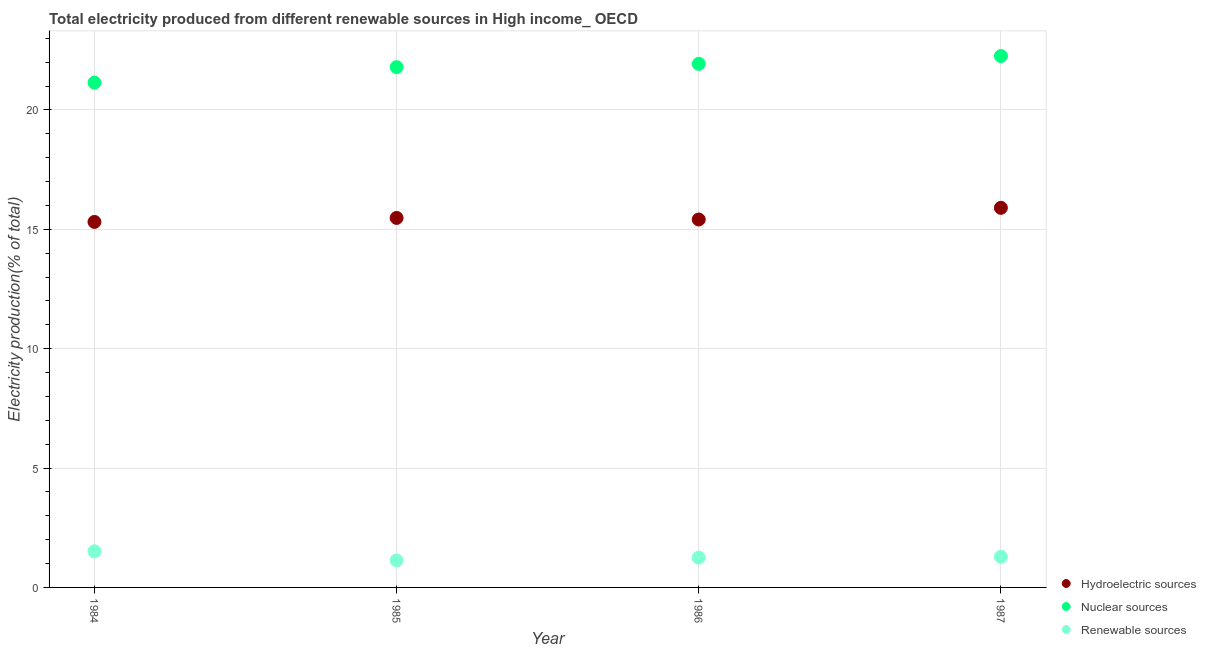How many different coloured dotlines are there?
Your answer should be compact. 3. Is the number of dotlines equal to the number of legend labels?
Ensure brevity in your answer.  Yes. What is the percentage of electricity produced by hydroelectric sources in 1987?
Ensure brevity in your answer.  15.9. Across all years, what is the maximum percentage of electricity produced by hydroelectric sources?
Keep it short and to the point. 15.9. Across all years, what is the minimum percentage of electricity produced by hydroelectric sources?
Provide a short and direct response. 15.31. What is the total percentage of electricity produced by hydroelectric sources in the graph?
Provide a succinct answer. 62.1. What is the difference between the percentage of electricity produced by nuclear sources in 1984 and that in 1985?
Your answer should be compact. -0.65. What is the difference between the percentage of electricity produced by renewable sources in 1985 and the percentage of electricity produced by nuclear sources in 1984?
Make the answer very short. -20.01. What is the average percentage of electricity produced by hydroelectric sources per year?
Offer a very short reply. 15.53. In the year 1986, what is the difference between the percentage of electricity produced by hydroelectric sources and percentage of electricity produced by nuclear sources?
Make the answer very short. -6.52. In how many years, is the percentage of electricity produced by renewable sources greater than 13 %?
Provide a short and direct response. 0. What is the ratio of the percentage of electricity produced by renewable sources in 1984 to that in 1987?
Your answer should be compact. 1.18. What is the difference between the highest and the second highest percentage of electricity produced by nuclear sources?
Ensure brevity in your answer.  0.33. What is the difference between the highest and the lowest percentage of electricity produced by renewable sources?
Provide a succinct answer. 0.38. In how many years, is the percentage of electricity produced by hydroelectric sources greater than the average percentage of electricity produced by hydroelectric sources taken over all years?
Ensure brevity in your answer.  1. Is the sum of the percentage of electricity produced by nuclear sources in 1985 and 1986 greater than the maximum percentage of electricity produced by hydroelectric sources across all years?
Your response must be concise. Yes. Is it the case that in every year, the sum of the percentage of electricity produced by hydroelectric sources and percentage of electricity produced by nuclear sources is greater than the percentage of electricity produced by renewable sources?
Provide a short and direct response. Yes. Is the percentage of electricity produced by nuclear sources strictly less than the percentage of electricity produced by renewable sources over the years?
Offer a very short reply. No. How many years are there in the graph?
Your answer should be compact. 4. What is the difference between two consecutive major ticks on the Y-axis?
Make the answer very short. 5. Are the values on the major ticks of Y-axis written in scientific E-notation?
Provide a succinct answer. No. Does the graph contain grids?
Make the answer very short. Yes. Where does the legend appear in the graph?
Offer a very short reply. Bottom right. How many legend labels are there?
Make the answer very short. 3. How are the legend labels stacked?
Provide a succinct answer. Vertical. What is the title of the graph?
Make the answer very short. Total electricity produced from different renewable sources in High income_ OECD. Does "Agricultural raw materials" appear as one of the legend labels in the graph?
Offer a very short reply. No. What is the label or title of the Y-axis?
Offer a terse response. Electricity production(% of total). What is the Electricity production(% of total) of Hydroelectric sources in 1984?
Offer a terse response. 15.31. What is the Electricity production(% of total) of Nuclear sources in 1984?
Offer a very short reply. 21.14. What is the Electricity production(% of total) of Renewable sources in 1984?
Your response must be concise. 1.51. What is the Electricity production(% of total) of Hydroelectric sources in 1985?
Your response must be concise. 15.48. What is the Electricity production(% of total) in Nuclear sources in 1985?
Keep it short and to the point. 21.79. What is the Electricity production(% of total) of Renewable sources in 1985?
Provide a short and direct response. 1.13. What is the Electricity production(% of total) in Hydroelectric sources in 1986?
Keep it short and to the point. 15.41. What is the Electricity production(% of total) in Nuclear sources in 1986?
Your response must be concise. 21.93. What is the Electricity production(% of total) of Renewable sources in 1986?
Your response must be concise. 1.25. What is the Electricity production(% of total) of Hydroelectric sources in 1987?
Offer a terse response. 15.9. What is the Electricity production(% of total) of Nuclear sources in 1987?
Keep it short and to the point. 22.26. What is the Electricity production(% of total) of Renewable sources in 1987?
Offer a terse response. 1.28. Across all years, what is the maximum Electricity production(% of total) in Hydroelectric sources?
Offer a terse response. 15.9. Across all years, what is the maximum Electricity production(% of total) in Nuclear sources?
Your answer should be very brief. 22.26. Across all years, what is the maximum Electricity production(% of total) of Renewable sources?
Give a very brief answer. 1.51. Across all years, what is the minimum Electricity production(% of total) in Hydroelectric sources?
Provide a succinct answer. 15.31. Across all years, what is the minimum Electricity production(% of total) of Nuclear sources?
Provide a short and direct response. 21.14. Across all years, what is the minimum Electricity production(% of total) in Renewable sources?
Give a very brief answer. 1.13. What is the total Electricity production(% of total) in Hydroelectric sources in the graph?
Offer a terse response. 62.1. What is the total Electricity production(% of total) of Nuclear sources in the graph?
Give a very brief answer. 87.13. What is the total Electricity production(% of total) of Renewable sources in the graph?
Keep it short and to the point. 5.18. What is the difference between the Electricity production(% of total) in Hydroelectric sources in 1984 and that in 1985?
Offer a very short reply. -0.17. What is the difference between the Electricity production(% of total) of Nuclear sources in 1984 and that in 1985?
Give a very brief answer. -0.65. What is the difference between the Electricity production(% of total) in Renewable sources in 1984 and that in 1985?
Give a very brief answer. 0.38. What is the difference between the Electricity production(% of total) of Hydroelectric sources in 1984 and that in 1986?
Keep it short and to the point. -0.1. What is the difference between the Electricity production(% of total) in Nuclear sources in 1984 and that in 1986?
Keep it short and to the point. -0.79. What is the difference between the Electricity production(% of total) of Renewable sources in 1984 and that in 1986?
Your answer should be very brief. 0.26. What is the difference between the Electricity production(% of total) of Hydroelectric sources in 1984 and that in 1987?
Your answer should be compact. -0.59. What is the difference between the Electricity production(% of total) of Nuclear sources in 1984 and that in 1987?
Provide a succinct answer. -1.12. What is the difference between the Electricity production(% of total) in Renewable sources in 1984 and that in 1987?
Your answer should be compact. 0.23. What is the difference between the Electricity production(% of total) of Hydroelectric sources in 1985 and that in 1986?
Provide a short and direct response. 0.07. What is the difference between the Electricity production(% of total) in Nuclear sources in 1985 and that in 1986?
Offer a terse response. -0.14. What is the difference between the Electricity production(% of total) in Renewable sources in 1985 and that in 1986?
Make the answer very short. -0.12. What is the difference between the Electricity production(% of total) in Hydroelectric sources in 1985 and that in 1987?
Your answer should be compact. -0.42. What is the difference between the Electricity production(% of total) of Nuclear sources in 1985 and that in 1987?
Offer a terse response. -0.47. What is the difference between the Electricity production(% of total) in Renewable sources in 1985 and that in 1987?
Offer a terse response. -0.15. What is the difference between the Electricity production(% of total) in Hydroelectric sources in 1986 and that in 1987?
Provide a succinct answer. -0.49. What is the difference between the Electricity production(% of total) in Nuclear sources in 1986 and that in 1987?
Ensure brevity in your answer.  -0.33. What is the difference between the Electricity production(% of total) in Renewable sources in 1986 and that in 1987?
Make the answer very short. -0.04. What is the difference between the Electricity production(% of total) of Hydroelectric sources in 1984 and the Electricity production(% of total) of Nuclear sources in 1985?
Offer a very short reply. -6.48. What is the difference between the Electricity production(% of total) in Hydroelectric sources in 1984 and the Electricity production(% of total) in Renewable sources in 1985?
Provide a succinct answer. 14.18. What is the difference between the Electricity production(% of total) in Nuclear sources in 1984 and the Electricity production(% of total) in Renewable sources in 1985?
Your answer should be compact. 20.01. What is the difference between the Electricity production(% of total) of Hydroelectric sources in 1984 and the Electricity production(% of total) of Nuclear sources in 1986?
Ensure brevity in your answer.  -6.62. What is the difference between the Electricity production(% of total) of Hydroelectric sources in 1984 and the Electricity production(% of total) of Renewable sources in 1986?
Your response must be concise. 14.06. What is the difference between the Electricity production(% of total) in Nuclear sources in 1984 and the Electricity production(% of total) in Renewable sources in 1986?
Offer a terse response. 19.9. What is the difference between the Electricity production(% of total) of Hydroelectric sources in 1984 and the Electricity production(% of total) of Nuclear sources in 1987?
Ensure brevity in your answer.  -6.95. What is the difference between the Electricity production(% of total) in Hydroelectric sources in 1984 and the Electricity production(% of total) in Renewable sources in 1987?
Ensure brevity in your answer.  14.03. What is the difference between the Electricity production(% of total) in Nuclear sources in 1984 and the Electricity production(% of total) in Renewable sources in 1987?
Ensure brevity in your answer.  19.86. What is the difference between the Electricity production(% of total) of Hydroelectric sources in 1985 and the Electricity production(% of total) of Nuclear sources in 1986?
Your response must be concise. -6.46. What is the difference between the Electricity production(% of total) of Hydroelectric sources in 1985 and the Electricity production(% of total) of Renewable sources in 1986?
Provide a short and direct response. 14.23. What is the difference between the Electricity production(% of total) of Nuclear sources in 1985 and the Electricity production(% of total) of Renewable sources in 1986?
Your answer should be very brief. 20.55. What is the difference between the Electricity production(% of total) in Hydroelectric sources in 1985 and the Electricity production(% of total) in Nuclear sources in 1987?
Your answer should be very brief. -6.78. What is the difference between the Electricity production(% of total) of Hydroelectric sources in 1985 and the Electricity production(% of total) of Renewable sources in 1987?
Provide a short and direct response. 14.19. What is the difference between the Electricity production(% of total) in Nuclear sources in 1985 and the Electricity production(% of total) in Renewable sources in 1987?
Provide a succinct answer. 20.51. What is the difference between the Electricity production(% of total) in Hydroelectric sources in 1986 and the Electricity production(% of total) in Nuclear sources in 1987?
Offer a terse response. -6.85. What is the difference between the Electricity production(% of total) of Hydroelectric sources in 1986 and the Electricity production(% of total) of Renewable sources in 1987?
Keep it short and to the point. 14.13. What is the difference between the Electricity production(% of total) in Nuclear sources in 1986 and the Electricity production(% of total) in Renewable sources in 1987?
Provide a short and direct response. 20.65. What is the average Electricity production(% of total) in Hydroelectric sources per year?
Give a very brief answer. 15.53. What is the average Electricity production(% of total) of Nuclear sources per year?
Keep it short and to the point. 21.78. What is the average Electricity production(% of total) of Renewable sources per year?
Give a very brief answer. 1.29. In the year 1984, what is the difference between the Electricity production(% of total) in Hydroelectric sources and Electricity production(% of total) in Nuclear sources?
Make the answer very short. -5.83. In the year 1984, what is the difference between the Electricity production(% of total) of Hydroelectric sources and Electricity production(% of total) of Renewable sources?
Offer a very short reply. 13.8. In the year 1984, what is the difference between the Electricity production(% of total) of Nuclear sources and Electricity production(% of total) of Renewable sources?
Provide a succinct answer. 19.63. In the year 1985, what is the difference between the Electricity production(% of total) of Hydroelectric sources and Electricity production(% of total) of Nuclear sources?
Provide a short and direct response. -6.32. In the year 1985, what is the difference between the Electricity production(% of total) in Hydroelectric sources and Electricity production(% of total) in Renewable sources?
Your answer should be compact. 14.35. In the year 1985, what is the difference between the Electricity production(% of total) of Nuclear sources and Electricity production(% of total) of Renewable sources?
Offer a terse response. 20.66. In the year 1986, what is the difference between the Electricity production(% of total) in Hydroelectric sources and Electricity production(% of total) in Nuclear sources?
Your answer should be very brief. -6.52. In the year 1986, what is the difference between the Electricity production(% of total) of Hydroelectric sources and Electricity production(% of total) of Renewable sources?
Your response must be concise. 14.16. In the year 1986, what is the difference between the Electricity production(% of total) in Nuclear sources and Electricity production(% of total) in Renewable sources?
Your answer should be compact. 20.68. In the year 1987, what is the difference between the Electricity production(% of total) of Hydroelectric sources and Electricity production(% of total) of Nuclear sources?
Ensure brevity in your answer.  -6.36. In the year 1987, what is the difference between the Electricity production(% of total) in Hydroelectric sources and Electricity production(% of total) in Renewable sources?
Your answer should be compact. 14.62. In the year 1987, what is the difference between the Electricity production(% of total) in Nuclear sources and Electricity production(% of total) in Renewable sources?
Ensure brevity in your answer.  20.98. What is the ratio of the Electricity production(% of total) in Hydroelectric sources in 1984 to that in 1985?
Your response must be concise. 0.99. What is the ratio of the Electricity production(% of total) in Nuclear sources in 1984 to that in 1985?
Offer a terse response. 0.97. What is the ratio of the Electricity production(% of total) of Renewable sources in 1984 to that in 1985?
Provide a succinct answer. 1.34. What is the ratio of the Electricity production(% of total) in Nuclear sources in 1984 to that in 1986?
Make the answer very short. 0.96. What is the ratio of the Electricity production(% of total) of Renewable sources in 1984 to that in 1986?
Keep it short and to the point. 1.21. What is the ratio of the Electricity production(% of total) in Hydroelectric sources in 1984 to that in 1987?
Ensure brevity in your answer.  0.96. What is the ratio of the Electricity production(% of total) in Nuclear sources in 1984 to that in 1987?
Provide a succinct answer. 0.95. What is the ratio of the Electricity production(% of total) of Renewable sources in 1984 to that in 1987?
Make the answer very short. 1.18. What is the ratio of the Electricity production(% of total) in Hydroelectric sources in 1985 to that in 1986?
Provide a succinct answer. 1. What is the ratio of the Electricity production(% of total) in Renewable sources in 1985 to that in 1986?
Give a very brief answer. 0.91. What is the ratio of the Electricity production(% of total) of Hydroelectric sources in 1985 to that in 1987?
Make the answer very short. 0.97. What is the ratio of the Electricity production(% of total) in Nuclear sources in 1985 to that in 1987?
Offer a very short reply. 0.98. What is the ratio of the Electricity production(% of total) in Renewable sources in 1985 to that in 1987?
Keep it short and to the point. 0.88. What is the ratio of the Electricity production(% of total) in Hydroelectric sources in 1986 to that in 1987?
Your answer should be very brief. 0.97. What is the ratio of the Electricity production(% of total) of Nuclear sources in 1986 to that in 1987?
Provide a short and direct response. 0.99. What is the ratio of the Electricity production(% of total) of Renewable sources in 1986 to that in 1987?
Offer a terse response. 0.97. What is the difference between the highest and the second highest Electricity production(% of total) of Hydroelectric sources?
Your answer should be very brief. 0.42. What is the difference between the highest and the second highest Electricity production(% of total) of Nuclear sources?
Your response must be concise. 0.33. What is the difference between the highest and the second highest Electricity production(% of total) in Renewable sources?
Make the answer very short. 0.23. What is the difference between the highest and the lowest Electricity production(% of total) in Hydroelectric sources?
Your response must be concise. 0.59. What is the difference between the highest and the lowest Electricity production(% of total) in Nuclear sources?
Your answer should be compact. 1.12. What is the difference between the highest and the lowest Electricity production(% of total) in Renewable sources?
Your answer should be very brief. 0.38. 